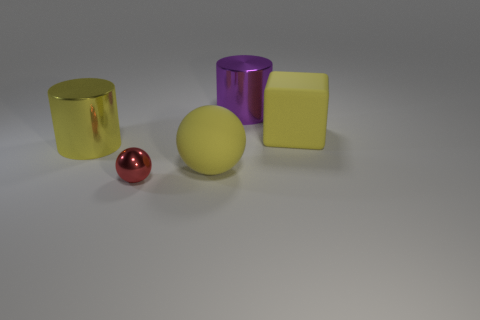Add 4 yellow cylinders. How many objects exist? 9 Subtract all blocks. How many objects are left? 4 Subtract all large green metallic spheres. Subtract all large matte objects. How many objects are left? 3 Add 4 small things. How many small things are left? 5 Add 2 purple shiny cylinders. How many purple shiny cylinders exist? 3 Subtract 0 cyan cylinders. How many objects are left? 5 